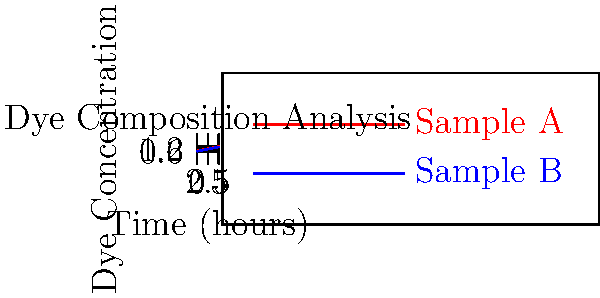Based on the dye composition analysis graphs for two textile fragments (Sample A and Sample B), which sample is likely to be older, assuming that dye degradation increases over time? To determine which sample is likely older, we need to analyze the dye concentration patterns:

1. Observe the initial dye concentrations:
   - Sample A (red line) starts at approximately 0.2
   - Sample B (blue line) starts at approximately 0.1

2. Compare the rate of increase in dye concentration:
   - Sample A shows a steeper slope
   - Sample B shows a more gradual increase

3. Consider the final dye concentrations:
   - Sample A reaches about 1.2 after 5 hours
   - Sample B reaches about 1.1 after 5 hours

4. Interpret the results:
   - Lower initial concentration and slower increase suggest more degradation
   - More degradation typically indicates an older sample

5. Conclusion:
   Sample B shows signs of more degradation (lower initial concentration, slower increase) and is therefore likely to be older.
Answer: Sample B 